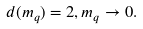Convert formula to latex. <formula><loc_0><loc_0><loc_500><loc_500>d ( m _ { q } ) = 2 , m _ { q } \rightarrow 0 .</formula> 